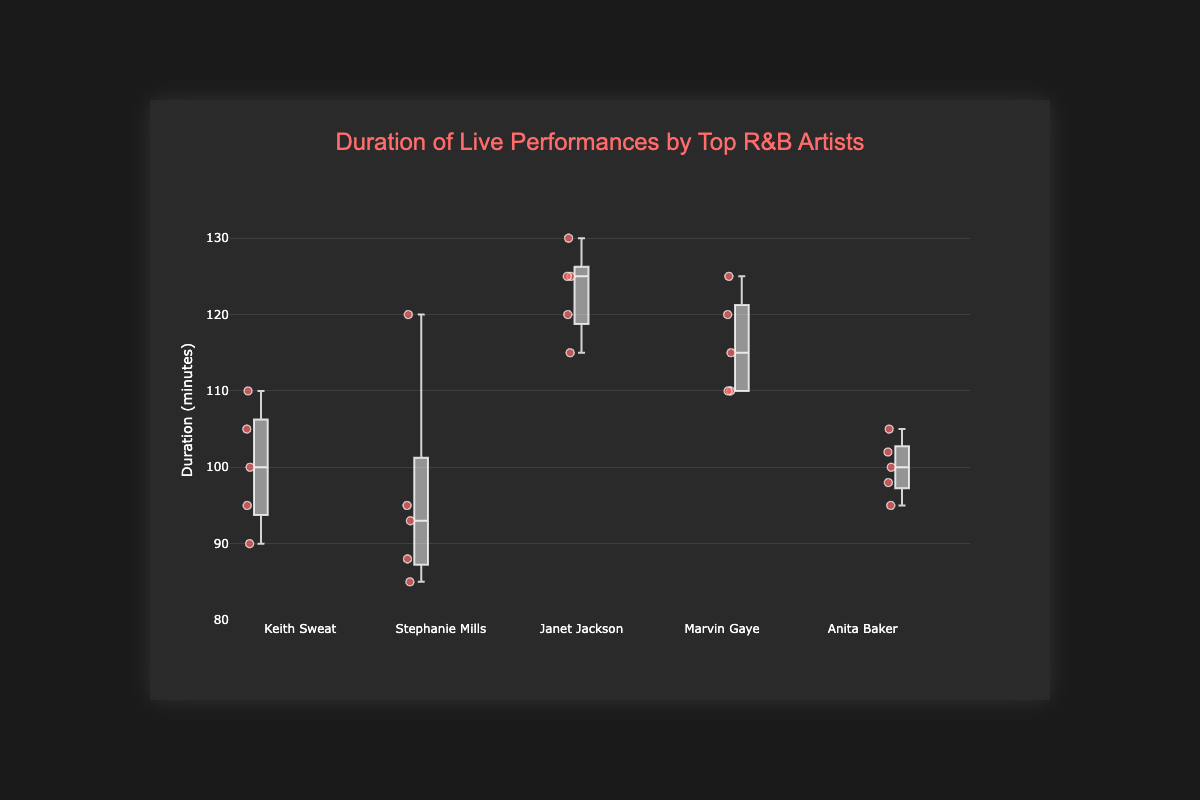What is the title of the box plot? The title of the box plot is usually displayed prominently at the top to describe what the chart represents. In this case, it is specified in the layout section of the code.
Answer: Duration of Live Performances by Top R&B Artists What is the range of the y-axis? The y-axis range is typically shown on the left side of the box plot and defines the minimum and maximum values. Here, it is explicitly specified in the y-axis configuration.
Answer: 80 to 135 Which artist has the highest median performance duration? To find the highest median performance duration, look for the middle value of each box plot. Janet Jackson's box plot is centered higher than any other artist's box plot, indicating the highest median.
Answer: Janet Jackson What is the duration of Keith Sweat's longest performance? Keith Sweat's longest performance duration corresponds to the highest point in his box. From the data and the positioning of the box plots, the maximum value is from the Hollywood Bowl.
Answer: 110 minutes Who had the most varied performance durations? The variation in performance durations is represented by the height of the box plot (interquartile range) and the entire spread of the data points. From the plots, Stephanie Mills has a wide spread, with durations ranging from the low 80s to 120, showing high variability.
Answer: Stephanie Mills How does Marvin Gaye's median performance duration compare to Anita Baker's? Compare the line in the middle of Marvin Gaye's box plot with Anita Baker's. Marvin Gaye's median is visually higher than Anita Baker's median.
Answer: Marvin Gaye's median is higher What is the shortest performance duration by Stephanie Mills? The shortest duration is represented by the lowest point in Stephanie Mills' box plot.
Answer: 85 minutes Which artist has the most consistent performance durations? Artists with the smallest interquartile range and smallest overall range have the most consistent performance durations. Anita Baker has the smallest box and smallest spread.
Answer: Anita Baker What’s the interquartile range of Janet Jackson’s performance durations? The interquartile range (IQR) is the range between the 25th and 75th percentiles, represented by the box's top and bottom. For Janet Jackson, it spans from 115 to 125 minutes.
Answer: 10 minutes At which venue did Stephanie Mills have her longest performance? Stephanie Mills' longest performance duration is indicated by the highest point of her box or data points. From the data, this is at the Hollywood Bowl.
Answer: Hollywood Bowl 